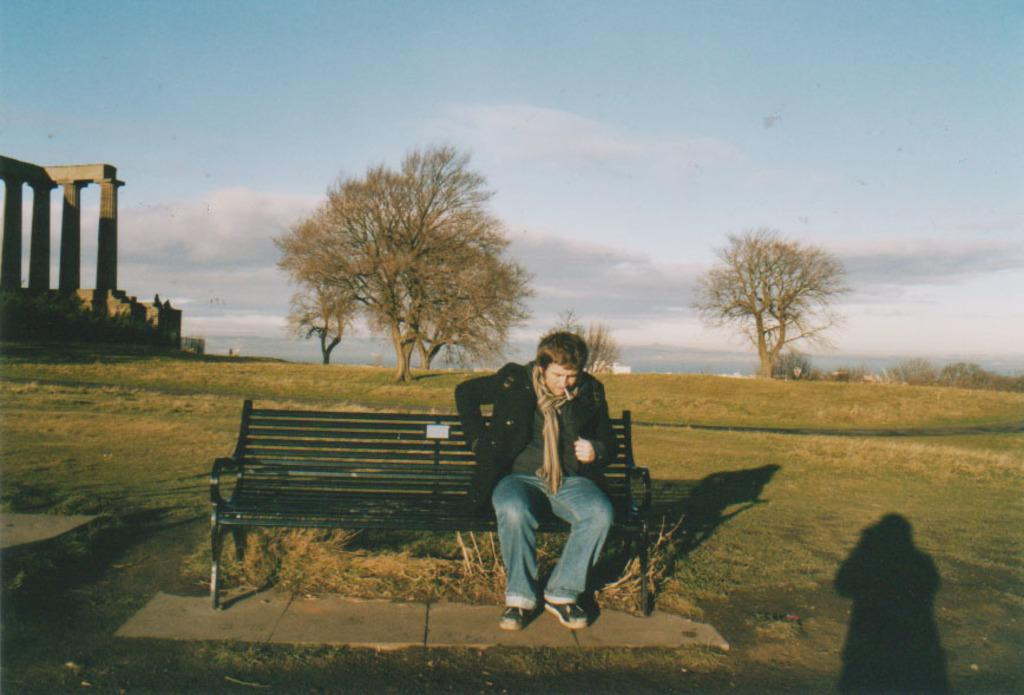What is the person in the image doing? A: The person is sitting on a bench. What is the person wearing in the image? The person is wearing a black dress. Can you describe any additional details about the person's appearance? There is a shadow of the person visible in the image. What can be seen behind the person? There are trees and pillars in the background, along with grass. What is visible in the sky in the background? The sky with clouds is visible in the background. What type of copper material is used to make the person's underwear in the image? There is no mention of underwear or copper in the image, so this information cannot be determined. 